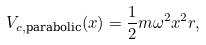<formula> <loc_0><loc_0><loc_500><loc_500>V _ { c , \text {parabolic} } ( x ) = \frac { 1 } { 2 } m \omega ^ { 2 } x ^ { 2 } r ,</formula> 